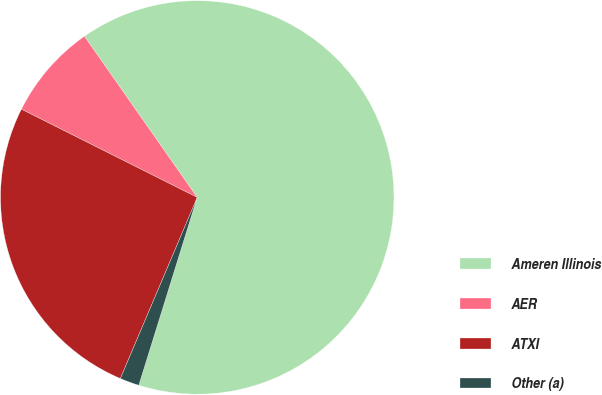Convert chart. <chart><loc_0><loc_0><loc_500><loc_500><pie_chart><fcel>Ameren Illinois<fcel>AER<fcel>ATXI<fcel>Other (a)<nl><fcel>64.52%<fcel>7.88%<fcel>26.01%<fcel>1.59%<nl></chart> 